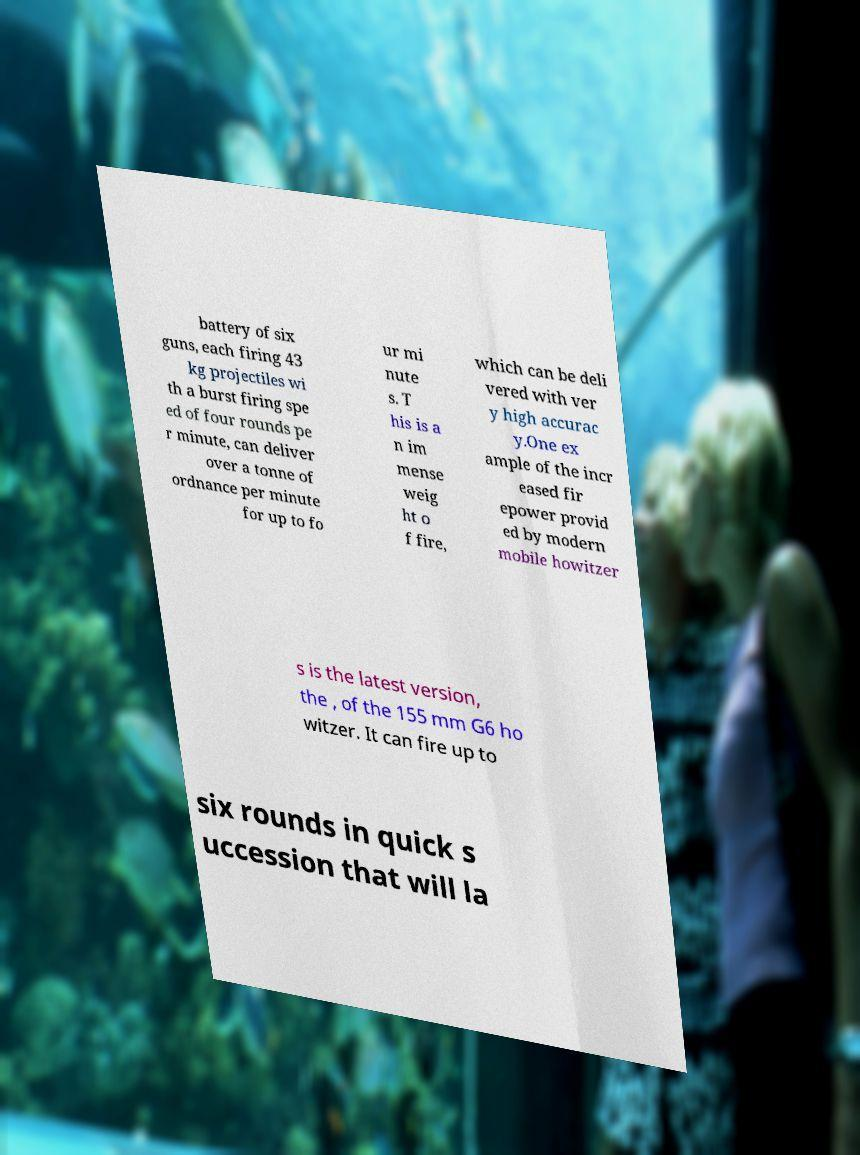What messages or text are displayed in this image? I need them in a readable, typed format. battery of six guns, each firing 43 kg projectiles wi th a burst firing spe ed of four rounds pe r minute, can deliver over a tonne of ordnance per minute for up to fo ur mi nute s. T his is a n im mense weig ht o f fire, which can be deli vered with ver y high accurac y.One ex ample of the incr eased fir epower provid ed by modern mobile howitzer s is the latest version, the , of the 155 mm G6 ho witzer. It can fire up to six rounds in quick s uccession that will la 